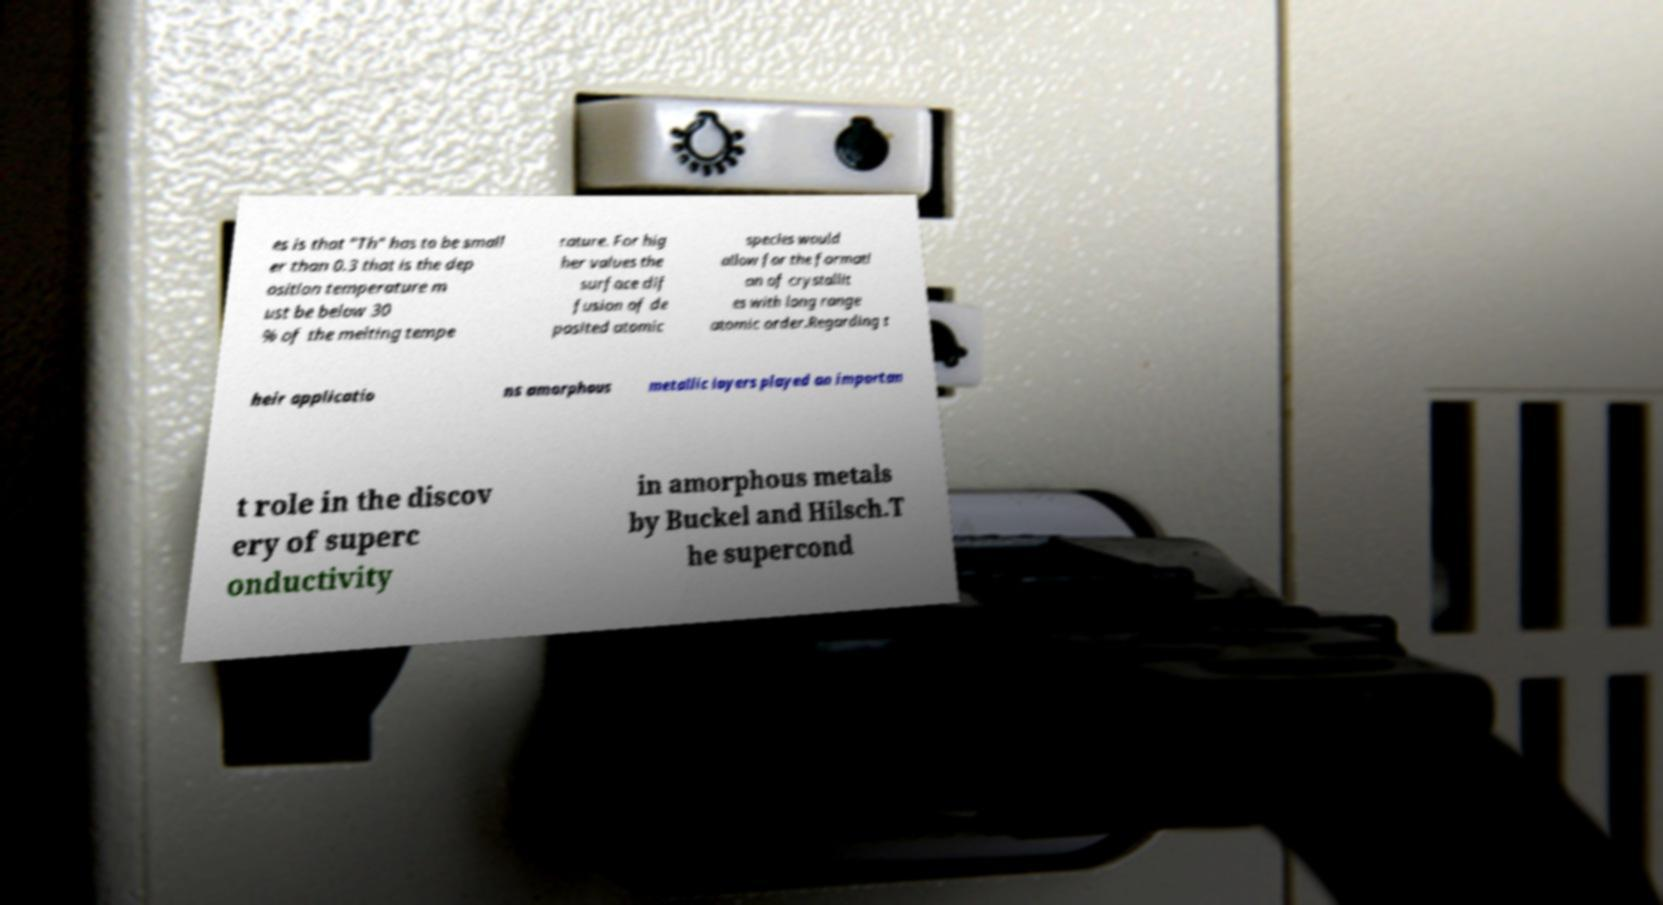For documentation purposes, I need the text within this image transcribed. Could you provide that? es is that "Th" has to be small er than 0.3 that is the dep osition temperature m ust be below 30 % of the melting tempe rature. For hig her values the surface dif fusion of de posited atomic species would allow for the formati on of crystallit es with long range atomic order.Regarding t heir applicatio ns amorphous metallic layers played an importan t role in the discov ery of superc onductivity in amorphous metals by Buckel and Hilsch.T he supercond 